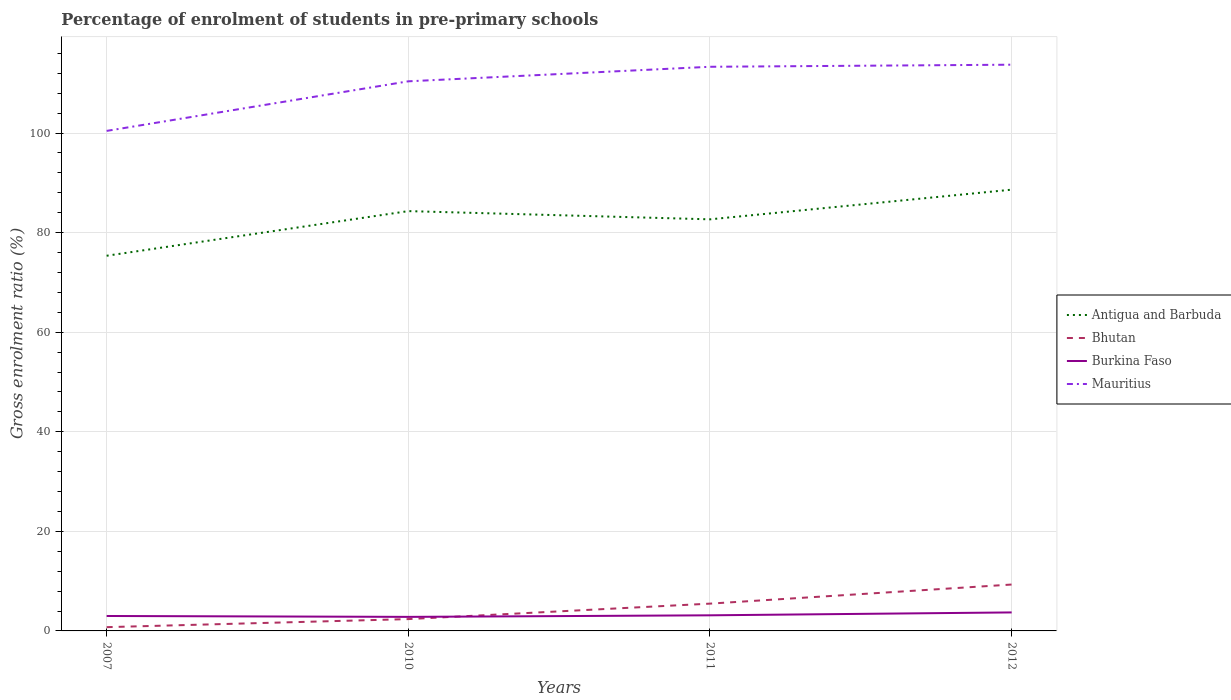How many different coloured lines are there?
Make the answer very short. 4. Does the line corresponding to Burkina Faso intersect with the line corresponding to Mauritius?
Offer a terse response. No. Is the number of lines equal to the number of legend labels?
Your response must be concise. Yes. Across all years, what is the maximum percentage of students enrolled in pre-primary schools in Burkina Faso?
Offer a very short reply. 2.82. In which year was the percentage of students enrolled in pre-primary schools in Bhutan maximum?
Your answer should be very brief. 2007. What is the total percentage of students enrolled in pre-primary schools in Mauritius in the graph?
Keep it short and to the point. -2.92. What is the difference between the highest and the second highest percentage of students enrolled in pre-primary schools in Bhutan?
Your answer should be very brief. 8.56. What is the difference between the highest and the lowest percentage of students enrolled in pre-primary schools in Burkina Faso?
Ensure brevity in your answer.  1. Is the percentage of students enrolled in pre-primary schools in Bhutan strictly greater than the percentage of students enrolled in pre-primary schools in Antigua and Barbuda over the years?
Offer a terse response. Yes. What is the title of the graph?
Your response must be concise. Percentage of enrolment of students in pre-primary schools. What is the Gross enrolment ratio (%) in Antigua and Barbuda in 2007?
Your answer should be very brief. 75.36. What is the Gross enrolment ratio (%) in Bhutan in 2007?
Give a very brief answer. 0.76. What is the Gross enrolment ratio (%) in Burkina Faso in 2007?
Your answer should be compact. 3. What is the Gross enrolment ratio (%) of Mauritius in 2007?
Your answer should be very brief. 100.44. What is the Gross enrolment ratio (%) of Antigua and Barbuda in 2010?
Keep it short and to the point. 84.32. What is the Gross enrolment ratio (%) of Bhutan in 2010?
Offer a terse response. 2.37. What is the Gross enrolment ratio (%) in Burkina Faso in 2010?
Your answer should be compact. 2.82. What is the Gross enrolment ratio (%) of Mauritius in 2010?
Your response must be concise. 110.39. What is the Gross enrolment ratio (%) in Antigua and Barbuda in 2011?
Make the answer very short. 82.67. What is the Gross enrolment ratio (%) of Bhutan in 2011?
Your response must be concise. 5.48. What is the Gross enrolment ratio (%) of Burkina Faso in 2011?
Offer a very short reply. 3.14. What is the Gross enrolment ratio (%) of Mauritius in 2011?
Keep it short and to the point. 113.31. What is the Gross enrolment ratio (%) in Antigua and Barbuda in 2012?
Ensure brevity in your answer.  88.63. What is the Gross enrolment ratio (%) in Bhutan in 2012?
Offer a very short reply. 9.32. What is the Gross enrolment ratio (%) in Burkina Faso in 2012?
Provide a short and direct response. 3.72. What is the Gross enrolment ratio (%) of Mauritius in 2012?
Keep it short and to the point. 113.73. Across all years, what is the maximum Gross enrolment ratio (%) of Antigua and Barbuda?
Offer a very short reply. 88.63. Across all years, what is the maximum Gross enrolment ratio (%) in Bhutan?
Provide a succinct answer. 9.32. Across all years, what is the maximum Gross enrolment ratio (%) in Burkina Faso?
Your answer should be compact. 3.72. Across all years, what is the maximum Gross enrolment ratio (%) in Mauritius?
Offer a very short reply. 113.73. Across all years, what is the minimum Gross enrolment ratio (%) of Antigua and Barbuda?
Give a very brief answer. 75.36. Across all years, what is the minimum Gross enrolment ratio (%) of Bhutan?
Ensure brevity in your answer.  0.76. Across all years, what is the minimum Gross enrolment ratio (%) of Burkina Faso?
Offer a terse response. 2.82. Across all years, what is the minimum Gross enrolment ratio (%) in Mauritius?
Provide a succinct answer. 100.44. What is the total Gross enrolment ratio (%) in Antigua and Barbuda in the graph?
Ensure brevity in your answer.  330.98. What is the total Gross enrolment ratio (%) in Bhutan in the graph?
Keep it short and to the point. 17.93. What is the total Gross enrolment ratio (%) in Burkina Faso in the graph?
Provide a succinct answer. 12.68. What is the total Gross enrolment ratio (%) in Mauritius in the graph?
Your answer should be compact. 437.88. What is the difference between the Gross enrolment ratio (%) of Antigua and Barbuda in 2007 and that in 2010?
Provide a short and direct response. -8.97. What is the difference between the Gross enrolment ratio (%) of Bhutan in 2007 and that in 2010?
Your answer should be very brief. -1.62. What is the difference between the Gross enrolment ratio (%) of Burkina Faso in 2007 and that in 2010?
Your response must be concise. 0.18. What is the difference between the Gross enrolment ratio (%) of Mauritius in 2007 and that in 2010?
Ensure brevity in your answer.  -9.96. What is the difference between the Gross enrolment ratio (%) in Antigua and Barbuda in 2007 and that in 2011?
Your answer should be compact. -7.31. What is the difference between the Gross enrolment ratio (%) of Bhutan in 2007 and that in 2011?
Your answer should be compact. -4.72. What is the difference between the Gross enrolment ratio (%) in Burkina Faso in 2007 and that in 2011?
Your answer should be very brief. -0.14. What is the difference between the Gross enrolment ratio (%) in Mauritius in 2007 and that in 2011?
Provide a short and direct response. -12.88. What is the difference between the Gross enrolment ratio (%) in Antigua and Barbuda in 2007 and that in 2012?
Keep it short and to the point. -13.27. What is the difference between the Gross enrolment ratio (%) in Bhutan in 2007 and that in 2012?
Your response must be concise. -8.56. What is the difference between the Gross enrolment ratio (%) of Burkina Faso in 2007 and that in 2012?
Your answer should be very brief. -0.71. What is the difference between the Gross enrolment ratio (%) of Mauritius in 2007 and that in 2012?
Offer a very short reply. -13.3. What is the difference between the Gross enrolment ratio (%) of Antigua and Barbuda in 2010 and that in 2011?
Provide a succinct answer. 1.65. What is the difference between the Gross enrolment ratio (%) of Bhutan in 2010 and that in 2011?
Give a very brief answer. -3.11. What is the difference between the Gross enrolment ratio (%) in Burkina Faso in 2010 and that in 2011?
Offer a very short reply. -0.31. What is the difference between the Gross enrolment ratio (%) in Mauritius in 2010 and that in 2011?
Keep it short and to the point. -2.92. What is the difference between the Gross enrolment ratio (%) of Antigua and Barbuda in 2010 and that in 2012?
Your response must be concise. -4.31. What is the difference between the Gross enrolment ratio (%) in Bhutan in 2010 and that in 2012?
Your response must be concise. -6.94. What is the difference between the Gross enrolment ratio (%) of Burkina Faso in 2010 and that in 2012?
Your answer should be very brief. -0.89. What is the difference between the Gross enrolment ratio (%) in Mauritius in 2010 and that in 2012?
Your response must be concise. -3.34. What is the difference between the Gross enrolment ratio (%) in Antigua and Barbuda in 2011 and that in 2012?
Provide a short and direct response. -5.96. What is the difference between the Gross enrolment ratio (%) of Bhutan in 2011 and that in 2012?
Give a very brief answer. -3.84. What is the difference between the Gross enrolment ratio (%) of Burkina Faso in 2011 and that in 2012?
Provide a succinct answer. -0.58. What is the difference between the Gross enrolment ratio (%) of Mauritius in 2011 and that in 2012?
Provide a succinct answer. -0.42. What is the difference between the Gross enrolment ratio (%) of Antigua and Barbuda in 2007 and the Gross enrolment ratio (%) of Bhutan in 2010?
Your response must be concise. 72.98. What is the difference between the Gross enrolment ratio (%) of Antigua and Barbuda in 2007 and the Gross enrolment ratio (%) of Burkina Faso in 2010?
Ensure brevity in your answer.  72.54. What is the difference between the Gross enrolment ratio (%) in Antigua and Barbuda in 2007 and the Gross enrolment ratio (%) in Mauritius in 2010?
Give a very brief answer. -35.04. What is the difference between the Gross enrolment ratio (%) of Bhutan in 2007 and the Gross enrolment ratio (%) of Burkina Faso in 2010?
Provide a succinct answer. -2.07. What is the difference between the Gross enrolment ratio (%) in Bhutan in 2007 and the Gross enrolment ratio (%) in Mauritius in 2010?
Give a very brief answer. -109.64. What is the difference between the Gross enrolment ratio (%) of Burkina Faso in 2007 and the Gross enrolment ratio (%) of Mauritius in 2010?
Provide a succinct answer. -107.39. What is the difference between the Gross enrolment ratio (%) in Antigua and Barbuda in 2007 and the Gross enrolment ratio (%) in Bhutan in 2011?
Offer a terse response. 69.88. What is the difference between the Gross enrolment ratio (%) of Antigua and Barbuda in 2007 and the Gross enrolment ratio (%) of Burkina Faso in 2011?
Your answer should be compact. 72.22. What is the difference between the Gross enrolment ratio (%) of Antigua and Barbuda in 2007 and the Gross enrolment ratio (%) of Mauritius in 2011?
Offer a terse response. -37.96. What is the difference between the Gross enrolment ratio (%) in Bhutan in 2007 and the Gross enrolment ratio (%) in Burkina Faso in 2011?
Provide a short and direct response. -2.38. What is the difference between the Gross enrolment ratio (%) of Bhutan in 2007 and the Gross enrolment ratio (%) of Mauritius in 2011?
Offer a very short reply. -112.56. What is the difference between the Gross enrolment ratio (%) in Burkina Faso in 2007 and the Gross enrolment ratio (%) in Mauritius in 2011?
Provide a short and direct response. -110.31. What is the difference between the Gross enrolment ratio (%) in Antigua and Barbuda in 2007 and the Gross enrolment ratio (%) in Bhutan in 2012?
Provide a short and direct response. 66.04. What is the difference between the Gross enrolment ratio (%) of Antigua and Barbuda in 2007 and the Gross enrolment ratio (%) of Burkina Faso in 2012?
Your response must be concise. 71.64. What is the difference between the Gross enrolment ratio (%) of Antigua and Barbuda in 2007 and the Gross enrolment ratio (%) of Mauritius in 2012?
Provide a short and direct response. -38.37. What is the difference between the Gross enrolment ratio (%) in Bhutan in 2007 and the Gross enrolment ratio (%) in Burkina Faso in 2012?
Ensure brevity in your answer.  -2.96. What is the difference between the Gross enrolment ratio (%) of Bhutan in 2007 and the Gross enrolment ratio (%) of Mauritius in 2012?
Your answer should be very brief. -112.98. What is the difference between the Gross enrolment ratio (%) of Burkina Faso in 2007 and the Gross enrolment ratio (%) of Mauritius in 2012?
Keep it short and to the point. -110.73. What is the difference between the Gross enrolment ratio (%) in Antigua and Barbuda in 2010 and the Gross enrolment ratio (%) in Bhutan in 2011?
Your answer should be compact. 78.84. What is the difference between the Gross enrolment ratio (%) in Antigua and Barbuda in 2010 and the Gross enrolment ratio (%) in Burkina Faso in 2011?
Offer a terse response. 81.19. What is the difference between the Gross enrolment ratio (%) of Antigua and Barbuda in 2010 and the Gross enrolment ratio (%) of Mauritius in 2011?
Make the answer very short. -28.99. What is the difference between the Gross enrolment ratio (%) of Bhutan in 2010 and the Gross enrolment ratio (%) of Burkina Faso in 2011?
Keep it short and to the point. -0.76. What is the difference between the Gross enrolment ratio (%) in Bhutan in 2010 and the Gross enrolment ratio (%) in Mauritius in 2011?
Make the answer very short. -110.94. What is the difference between the Gross enrolment ratio (%) of Burkina Faso in 2010 and the Gross enrolment ratio (%) of Mauritius in 2011?
Ensure brevity in your answer.  -110.49. What is the difference between the Gross enrolment ratio (%) in Antigua and Barbuda in 2010 and the Gross enrolment ratio (%) in Bhutan in 2012?
Your answer should be compact. 75.01. What is the difference between the Gross enrolment ratio (%) of Antigua and Barbuda in 2010 and the Gross enrolment ratio (%) of Burkina Faso in 2012?
Your answer should be compact. 80.61. What is the difference between the Gross enrolment ratio (%) of Antigua and Barbuda in 2010 and the Gross enrolment ratio (%) of Mauritius in 2012?
Your response must be concise. -29.41. What is the difference between the Gross enrolment ratio (%) in Bhutan in 2010 and the Gross enrolment ratio (%) in Burkina Faso in 2012?
Your response must be concise. -1.34. What is the difference between the Gross enrolment ratio (%) in Bhutan in 2010 and the Gross enrolment ratio (%) in Mauritius in 2012?
Provide a succinct answer. -111.36. What is the difference between the Gross enrolment ratio (%) of Burkina Faso in 2010 and the Gross enrolment ratio (%) of Mauritius in 2012?
Offer a terse response. -110.91. What is the difference between the Gross enrolment ratio (%) in Antigua and Barbuda in 2011 and the Gross enrolment ratio (%) in Bhutan in 2012?
Give a very brief answer. 73.35. What is the difference between the Gross enrolment ratio (%) of Antigua and Barbuda in 2011 and the Gross enrolment ratio (%) of Burkina Faso in 2012?
Offer a terse response. 78.96. What is the difference between the Gross enrolment ratio (%) of Antigua and Barbuda in 2011 and the Gross enrolment ratio (%) of Mauritius in 2012?
Your answer should be compact. -31.06. What is the difference between the Gross enrolment ratio (%) in Bhutan in 2011 and the Gross enrolment ratio (%) in Burkina Faso in 2012?
Give a very brief answer. 1.77. What is the difference between the Gross enrolment ratio (%) in Bhutan in 2011 and the Gross enrolment ratio (%) in Mauritius in 2012?
Your response must be concise. -108.25. What is the difference between the Gross enrolment ratio (%) of Burkina Faso in 2011 and the Gross enrolment ratio (%) of Mauritius in 2012?
Your response must be concise. -110.6. What is the average Gross enrolment ratio (%) of Antigua and Barbuda per year?
Provide a short and direct response. 82.75. What is the average Gross enrolment ratio (%) of Bhutan per year?
Provide a short and direct response. 4.48. What is the average Gross enrolment ratio (%) of Burkina Faso per year?
Offer a terse response. 3.17. What is the average Gross enrolment ratio (%) in Mauritius per year?
Keep it short and to the point. 109.47. In the year 2007, what is the difference between the Gross enrolment ratio (%) of Antigua and Barbuda and Gross enrolment ratio (%) of Bhutan?
Your response must be concise. 74.6. In the year 2007, what is the difference between the Gross enrolment ratio (%) of Antigua and Barbuda and Gross enrolment ratio (%) of Burkina Faso?
Keep it short and to the point. 72.36. In the year 2007, what is the difference between the Gross enrolment ratio (%) of Antigua and Barbuda and Gross enrolment ratio (%) of Mauritius?
Make the answer very short. -25.08. In the year 2007, what is the difference between the Gross enrolment ratio (%) of Bhutan and Gross enrolment ratio (%) of Burkina Faso?
Your response must be concise. -2.25. In the year 2007, what is the difference between the Gross enrolment ratio (%) in Bhutan and Gross enrolment ratio (%) in Mauritius?
Offer a terse response. -99.68. In the year 2007, what is the difference between the Gross enrolment ratio (%) of Burkina Faso and Gross enrolment ratio (%) of Mauritius?
Give a very brief answer. -97.43. In the year 2010, what is the difference between the Gross enrolment ratio (%) of Antigua and Barbuda and Gross enrolment ratio (%) of Bhutan?
Offer a terse response. 81.95. In the year 2010, what is the difference between the Gross enrolment ratio (%) of Antigua and Barbuda and Gross enrolment ratio (%) of Burkina Faso?
Provide a succinct answer. 81.5. In the year 2010, what is the difference between the Gross enrolment ratio (%) of Antigua and Barbuda and Gross enrolment ratio (%) of Mauritius?
Offer a terse response. -26.07. In the year 2010, what is the difference between the Gross enrolment ratio (%) of Bhutan and Gross enrolment ratio (%) of Burkina Faso?
Give a very brief answer. -0.45. In the year 2010, what is the difference between the Gross enrolment ratio (%) in Bhutan and Gross enrolment ratio (%) in Mauritius?
Make the answer very short. -108.02. In the year 2010, what is the difference between the Gross enrolment ratio (%) in Burkina Faso and Gross enrolment ratio (%) in Mauritius?
Your answer should be compact. -107.57. In the year 2011, what is the difference between the Gross enrolment ratio (%) of Antigua and Barbuda and Gross enrolment ratio (%) of Bhutan?
Keep it short and to the point. 77.19. In the year 2011, what is the difference between the Gross enrolment ratio (%) in Antigua and Barbuda and Gross enrolment ratio (%) in Burkina Faso?
Provide a short and direct response. 79.54. In the year 2011, what is the difference between the Gross enrolment ratio (%) of Antigua and Barbuda and Gross enrolment ratio (%) of Mauritius?
Offer a terse response. -30.64. In the year 2011, what is the difference between the Gross enrolment ratio (%) of Bhutan and Gross enrolment ratio (%) of Burkina Faso?
Your answer should be compact. 2.34. In the year 2011, what is the difference between the Gross enrolment ratio (%) in Bhutan and Gross enrolment ratio (%) in Mauritius?
Provide a short and direct response. -107.83. In the year 2011, what is the difference between the Gross enrolment ratio (%) in Burkina Faso and Gross enrolment ratio (%) in Mauritius?
Your answer should be very brief. -110.18. In the year 2012, what is the difference between the Gross enrolment ratio (%) in Antigua and Barbuda and Gross enrolment ratio (%) in Bhutan?
Make the answer very short. 79.31. In the year 2012, what is the difference between the Gross enrolment ratio (%) in Antigua and Barbuda and Gross enrolment ratio (%) in Burkina Faso?
Provide a succinct answer. 84.92. In the year 2012, what is the difference between the Gross enrolment ratio (%) in Antigua and Barbuda and Gross enrolment ratio (%) in Mauritius?
Provide a short and direct response. -25.1. In the year 2012, what is the difference between the Gross enrolment ratio (%) in Bhutan and Gross enrolment ratio (%) in Burkina Faso?
Give a very brief answer. 5.6. In the year 2012, what is the difference between the Gross enrolment ratio (%) in Bhutan and Gross enrolment ratio (%) in Mauritius?
Keep it short and to the point. -104.41. In the year 2012, what is the difference between the Gross enrolment ratio (%) of Burkina Faso and Gross enrolment ratio (%) of Mauritius?
Offer a terse response. -110.02. What is the ratio of the Gross enrolment ratio (%) of Antigua and Barbuda in 2007 to that in 2010?
Provide a short and direct response. 0.89. What is the ratio of the Gross enrolment ratio (%) in Bhutan in 2007 to that in 2010?
Offer a very short reply. 0.32. What is the ratio of the Gross enrolment ratio (%) of Burkina Faso in 2007 to that in 2010?
Your answer should be compact. 1.06. What is the ratio of the Gross enrolment ratio (%) in Mauritius in 2007 to that in 2010?
Provide a succinct answer. 0.91. What is the ratio of the Gross enrolment ratio (%) of Antigua and Barbuda in 2007 to that in 2011?
Offer a terse response. 0.91. What is the ratio of the Gross enrolment ratio (%) of Bhutan in 2007 to that in 2011?
Your answer should be compact. 0.14. What is the ratio of the Gross enrolment ratio (%) in Burkina Faso in 2007 to that in 2011?
Provide a succinct answer. 0.96. What is the ratio of the Gross enrolment ratio (%) of Mauritius in 2007 to that in 2011?
Keep it short and to the point. 0.89. What is the ratio of the Gross enrolment ratio (%) in Antigua and Barbuda in 2007 to that in 2012?
Ensure brevity in your answer.  0.85. What is the ratio of the Gross enrolment ratio (%) in Bhutan in 2007 to that in 2012?
Provide a succinct answer. 0.08. What is the ratio of the Gross enrolment ratio (%) of Burkina Faso in 2007 to that in 2012?
Your response must be concise. 0.81. What is the ratio of the Gross enrolment ratio (%) in Mauritius in 2007 to that in 2012?
Give a very brief answer. 0.88. What is the ratio of the Gross enrolment ratio (%) of Antigua and Barbuda in 2010 to that in 2011?
Offer a terse response. 1.02. What is the ratio of the Gross enrolment ratio (%) in Bhutan in 2010 to that in 2011?
Ensure brevity in your answer.  0.43. What is the ratio of the Gross enrolment ratio (%) in Burkina Faso in 2010 to that in 2011?
Make the answer very short. 0.9. What is the ratio of the Gross enrolment ratio (%) of Mauritius in 2010 to that in 2011?
Provide a succinct answer. 0.97. What is the ratio of the Gross enrolment ratio (%) in Antigua and Barbuda in 2010 to that in 2012?
Your answer should be very brief. 0.95. What is the ratio of the Gross enrolment ratio (%) of Bhutan in 2010 to that in 2012?
Offer a terse response. 0.25. What is the ratio of the Gross enrolment ratio (%) in Burkina Faso in 2010 to that in 2012?
Offer a terse response. 0.76. What is the ratio of the Gross enrolment ratio (%) of Mauritius in 2010 to that in 2012?
Provide a succinct answer. 0.97. What is the ratio of the Gross enrolment ratio (%) of Antigua and Barbuda in 2011 to that in 2012?
Keep it short and to the point. 0.93. What is the ratio of the Gross enrolment ratio (%) of Bhutan in 2011 to that in 2012?
Offer a terse response. 0.59. What is the ratio of the Gross enrolment ratio (%) of Burkina Faso in 2011 to that in 2012?
Your response must be concise. 0.84. What is the ratio of the Gross enrolment ratio (%) of Mauritius in 2011 to that in 2012?
Your answer should be compact. 1. What is the difference between the highest and the second highest Gross enrolment ratio (%) in Antigua and Barbuda?
Your answer should be very brief. 4.31. What is the difference between the highest and the second highest Gross enrolment ratio (%) in Bhutan?
Your answer should be compact. 3.84. What is the difference between the highest and the second highest Gross enrolment ratio (%) in Burkina Faso?
Your answer should be very brief. 0.58. What is the difference between the highest and the second highest Gross enrolment ratio (%) in Mauritius?
Give a very brief answer. 0.42. What is the difference between the highest and the lowest Gross enrolment ratio (%) in Antigua and Barbuda?
Your answer should be very brief. 13.27. What is the difference between the highest and the lowest Gross enrolment ratio (%) of Bhutan?
Make the answer very short. 8.56. What is the difference between the highest and the lowest Gross enrolment ratio (%) in Burkina Faso?
Offer a terse response. 0.89. What is the difference between the highest and the lowest Gross enrolment ratio (%) of Mauritius?
Offer a terse response. 13.3. 